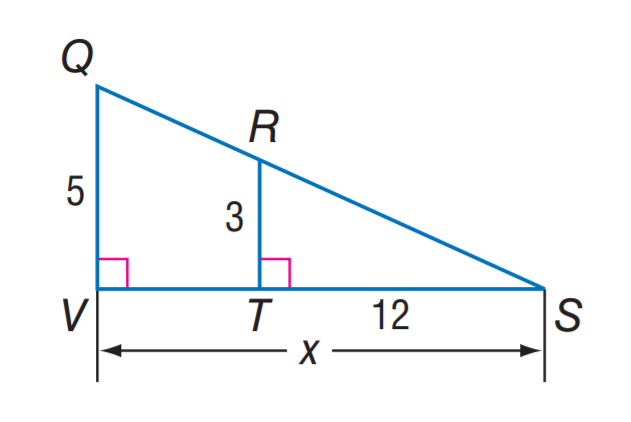Question: Find V S.
Choices:
A. 5
B. 12
C. 15
D. 20
Answer with the letter. Answer: D 